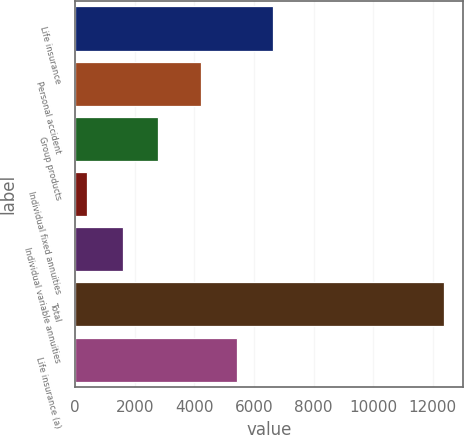Convert chart. <chart><loc_0><loc_0><loc_500><loc_500><bar_chart><fcel>Life insurance<fcel>Personal accident<fcel>Group products<fcel>Individual fixed annuities<fcel>Individual variable annuities<fcel>Total<fcel>Life insurance (a)<nl><fcel>6625.2<fcel>4225<fcel>2786.2<fcel>386<fcel>1586.1<fcel>12387<fcel>5425.1<nl></chart> 